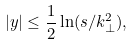<formula> <loc_0><loc_0><loc_500><loc_500>| y | \leq \frac { 1 } { 2 } \ln ( s / k _ { \perp } ^ { 2 } ) ,</formula> 